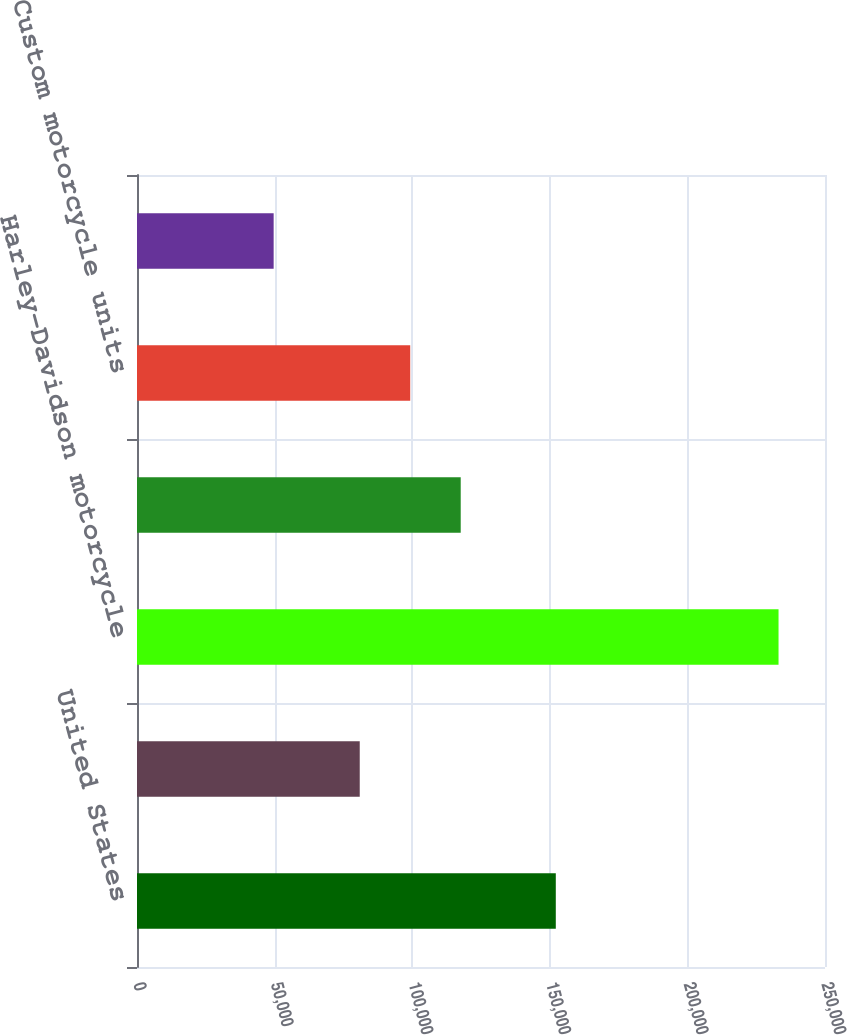Convert chart to OTSL. <chart><loc_0><loc_0><loc_500><loc_500><bar_chart><fcel>United States<fcel>International<fcel>Harley-Davidson motorcycle<fcel>Touring motorcycle units<fcel>Custom motorcycle units<fcel>Sportster motorcycle units<nl><fcel>152180<fcel>80937<fcel>233117<fcel>117629<fcel>99283.1<fcel>49656<nl></chart> 